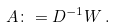<formula> <loc_0><loc_0><loc_500><loc_500>A \colon = D ^ { - 1 } W \, .</formula> 